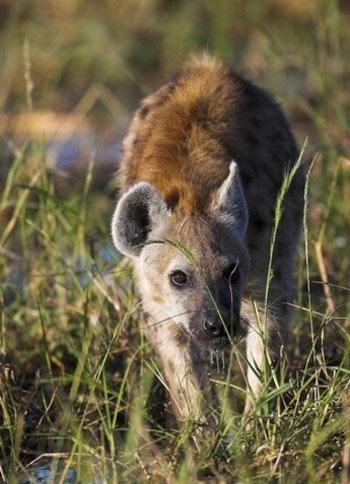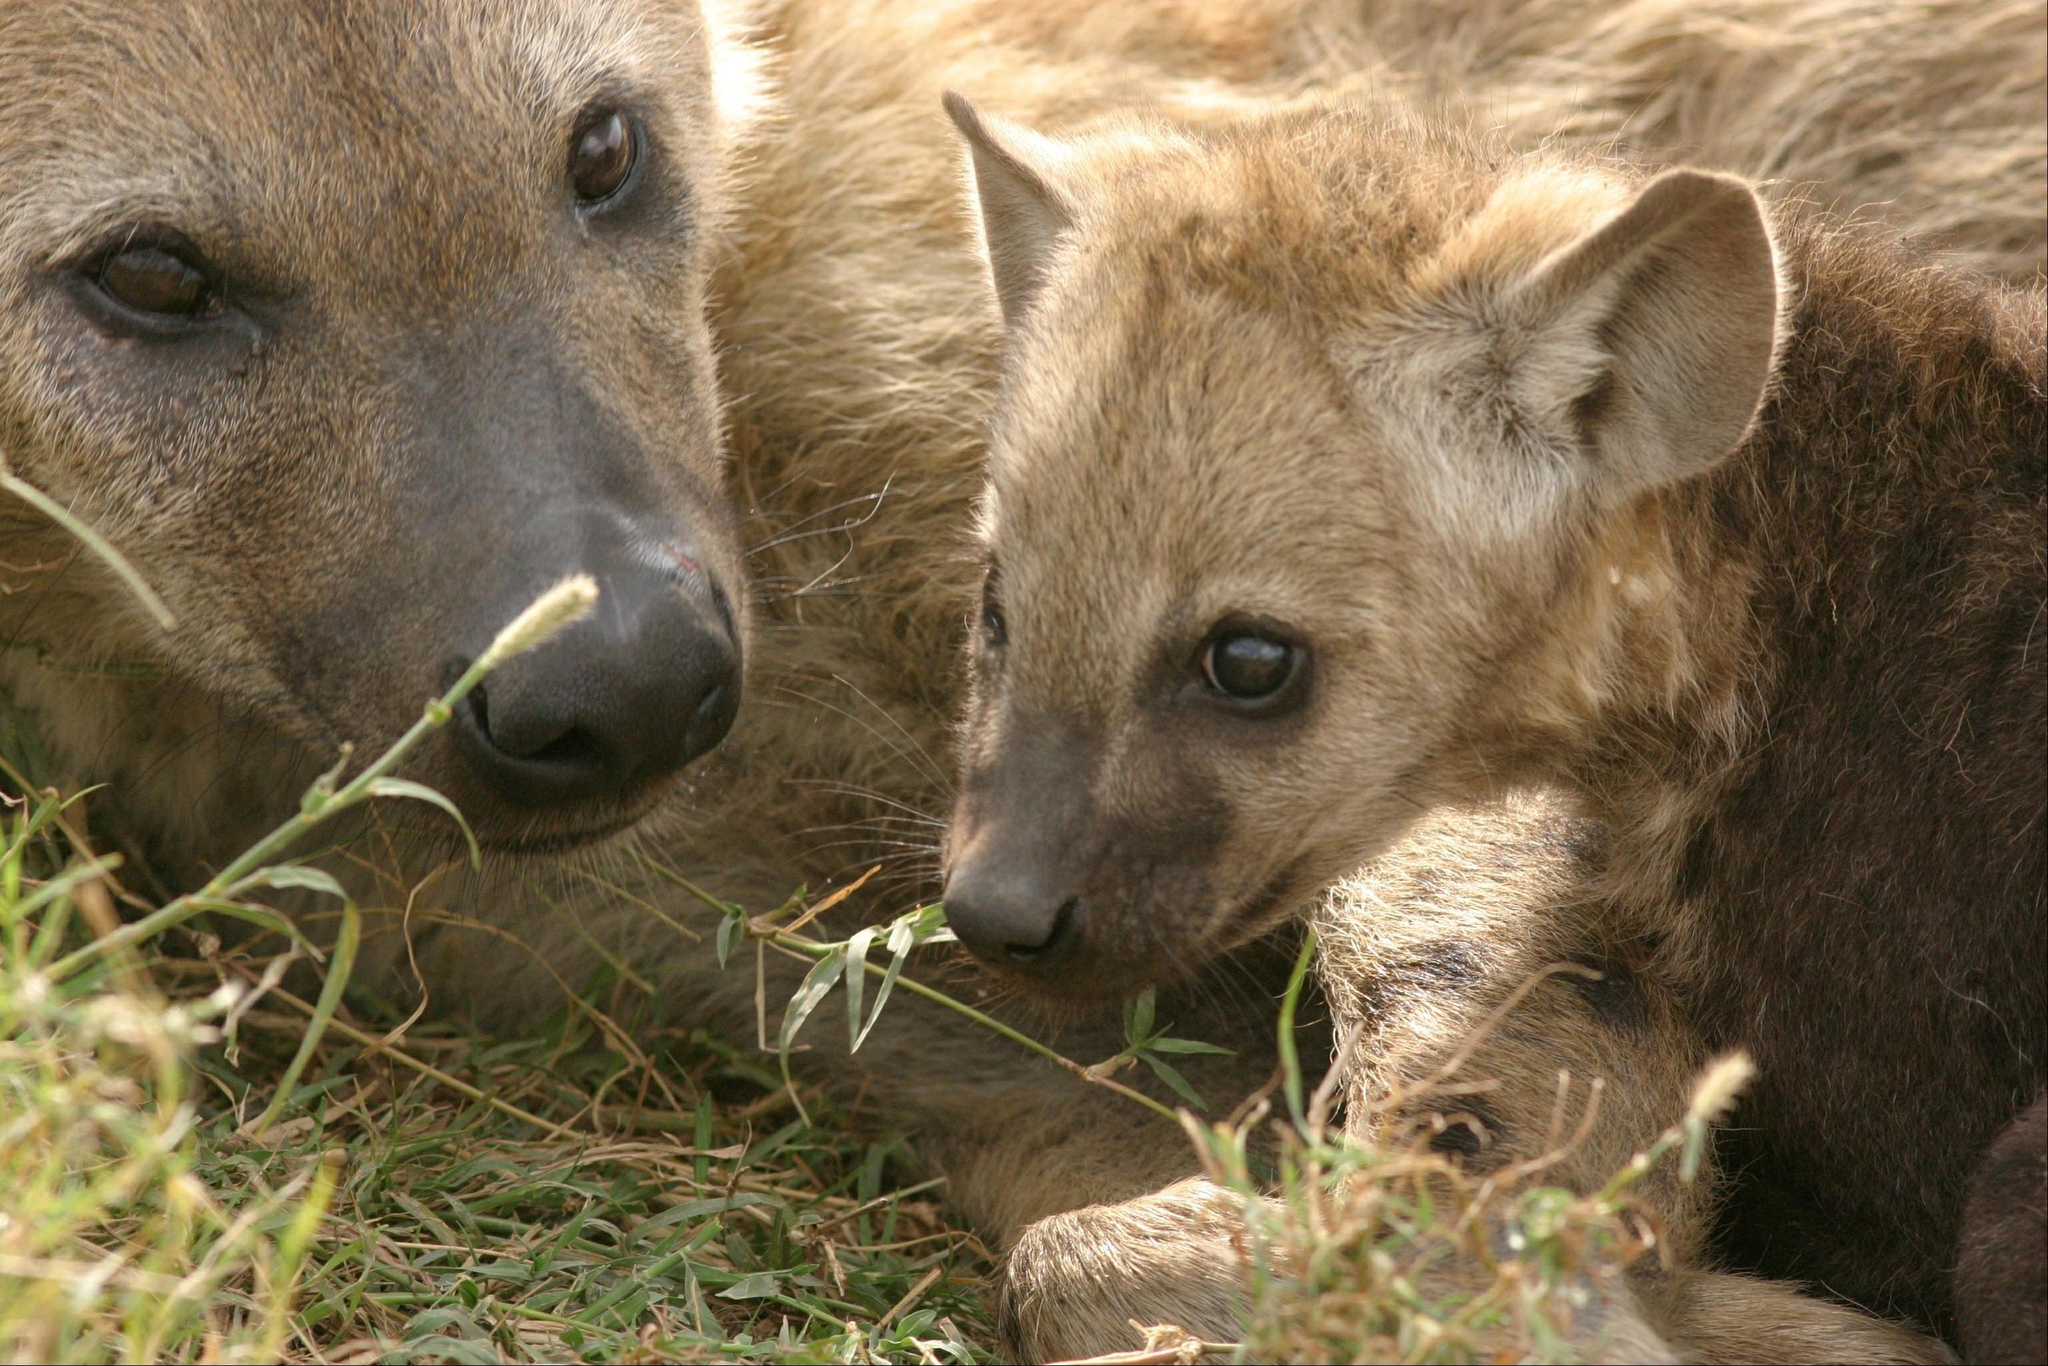The first image is the image on the left, the second image is the image on the right. Considering the images on both sides, is "There are hyena cubs laying with their moms" valid? Answer yes or no. Yes. The first image is the image on the left, the second image is the image on the right. Analyze the images presented: Is the assertion "An image shows an adult hyena lying with a much younger hyena." valid? Answer yes or no. Yes. 